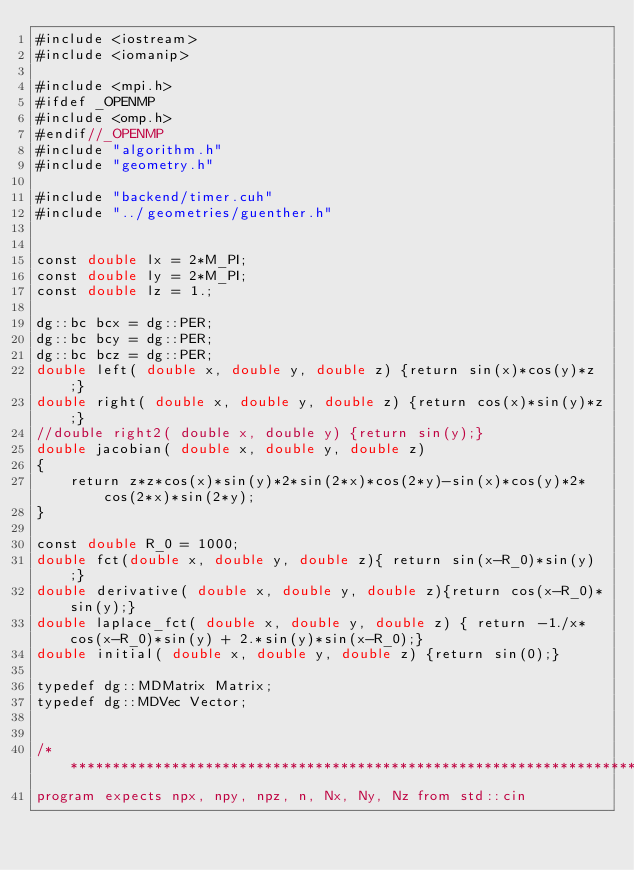Convert code to text. <code><loc_0><loc_0><loc_500><loc_500><_Cuda_>#include <iostream>
#include <iomanip>

#include <mpi.h>
#ifdef _OPENMP
#include <omp.h>
#endif//_OPENMP
#include "algorithm.h"
#include "geometry.h"

#include "backend/timer.cuh"
#include "../geometries/guenther.h"


const double lx = 2*M_PI;
const double ly = 2*M_PI;
const double lz = 1.;

dg::bc bcx = dg::PER;
dg::bc bcy = dg::PER;
dg::bc bcz = dg::PER;
double left( double x, double y, double z) {return sin(x)*cos(y)*z;}
double right( double x, double y, double z) {return cos(x)*sin(y)*z;} 
//double right2( double x, double y) {return sin(y);}
double jacobian( double x, double y, double z) 
{
    return z*z*cos(x)*sin(y)*2*sin(2*x)*cos(2*y)-sin(x)*cos(y)*2*cos(2*x)*sin(2*y);
}

const double R_0 = 1000;
double fct(double x, double y, double z){ return sin(x-R_0)*sin(y);}
double derivative( double x, double y, double z){return cos(x-R_0)*sin(y);}
double laplace_fct( double x, double y, double z) { return -1./x*cos(x-R_0)*sin(y) + 2.*sin(y)*sin(x-R_0);}
double initial( double x, double y, double z) {return sin(0);}

typedef dg::MDMatrix Matrix;
typedef dg::MDVec Vector;


/*******************************************************************************
program expects npx, npy, npz, n, Nx, Ny, Nz from std::cin</code> 